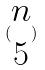Convert formula to latex. <formula><loc_0><loc_0><loc_500><loc_500>( \begin{matrix} n \\ 5 \end{matrix} )</formula> 